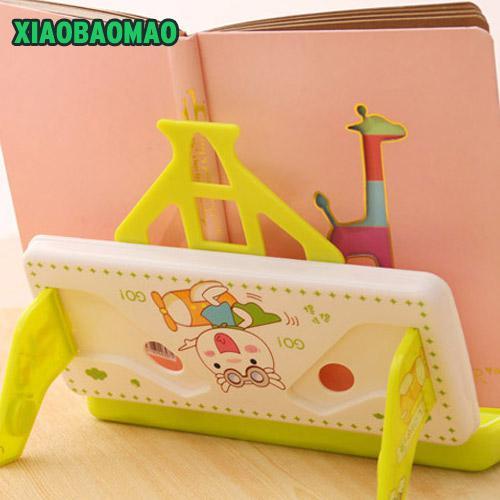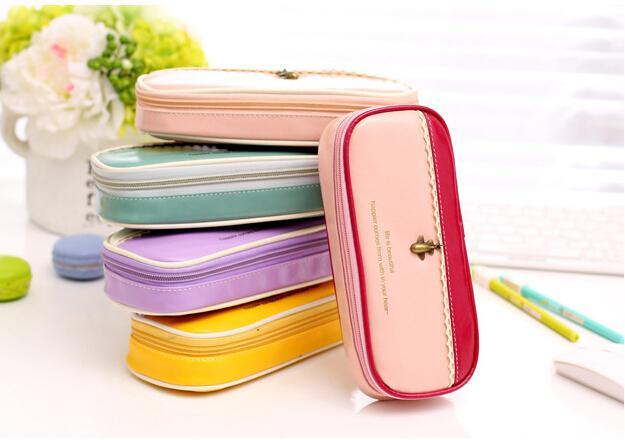The first image is the image on the left, the second image is the image on the right. Examine the images to the left and right. Is the description "There is one yellow pencil case with an additional 3 to 4 different colors cases visible." accurate? Answer yes or no. Yes. The first image is the image on the left, the second image is the image on the right. Assess this claim about the two images: "The image on the right contains no more than four handbags that are each a different color.". Correct or not? Answer yes or no. No. 